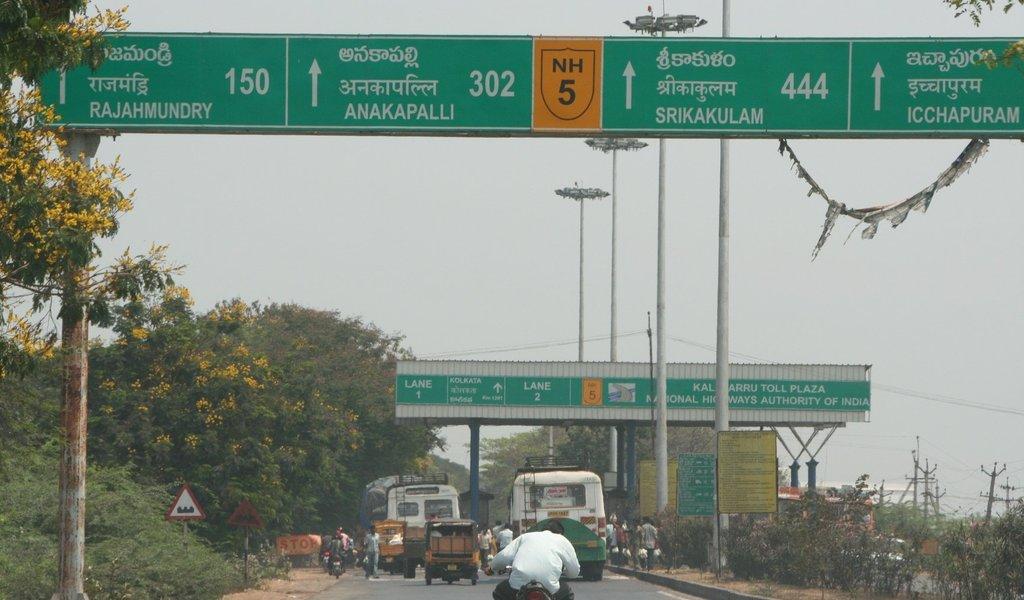What number nh is here?
Offer a terse response. 5. 